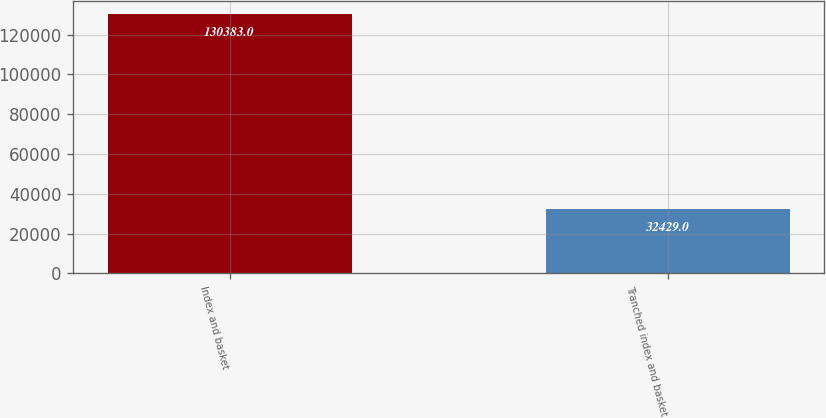<chart> <loc_0><loc_0><loc_500><loc_500><bar_chart><fcel>Index and basket<fcel>Tranched index and basket<nl><fcel>130383<fcel>32429<nl></chart> 